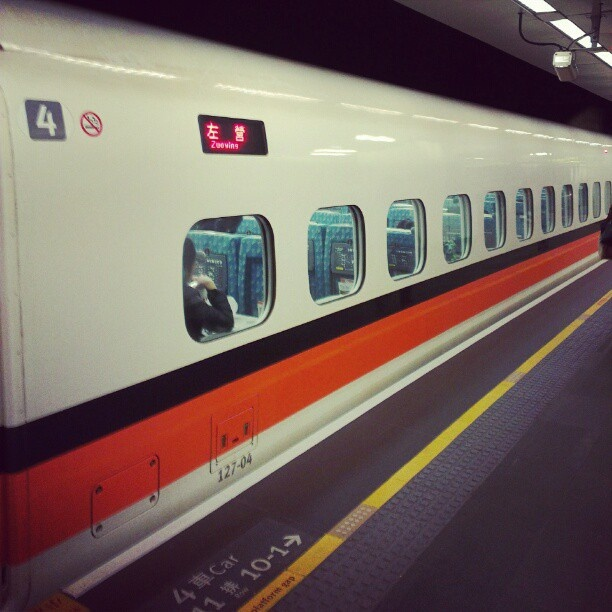Describe the objects in this image and their specific colors. I can see train in purple, darkgray, beige, black, and brown tones, people in purple, black, gray, and darkgray tones, people in purple, black, gray, and blue tones, and people in purple, gray, blue, and black tones in this image. 